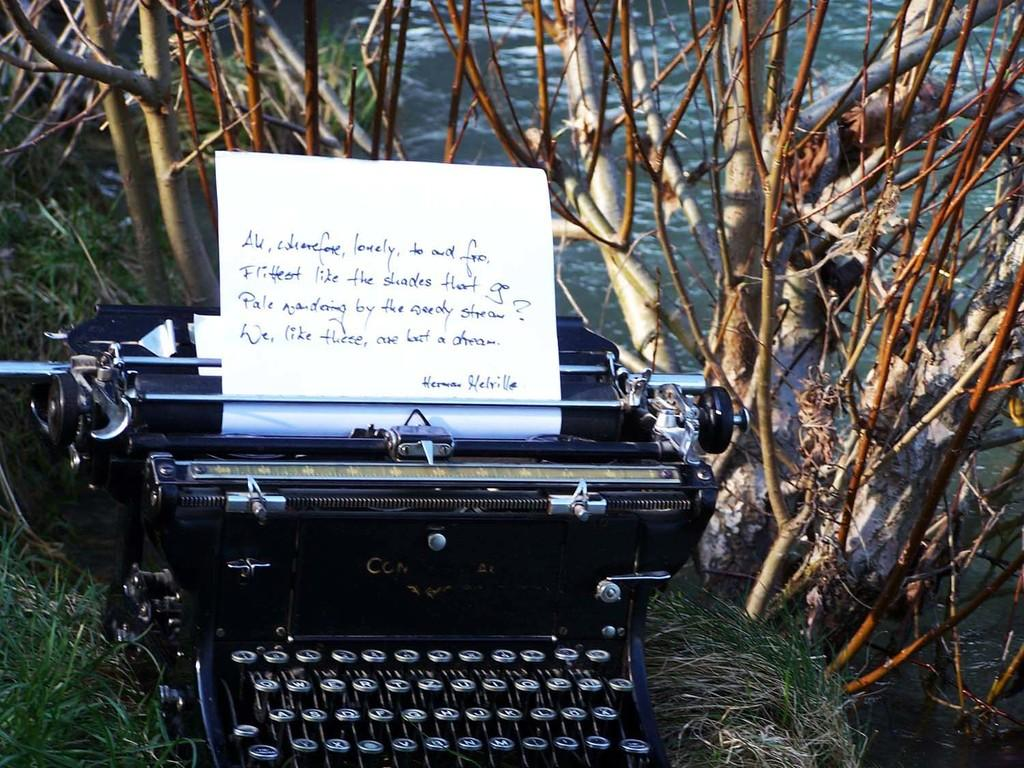Provide a one-sentence caption for the provided image. A piece of paper with handwriting on it that's signed by Herman Melville sticks out of an old fashioned typewriter. 